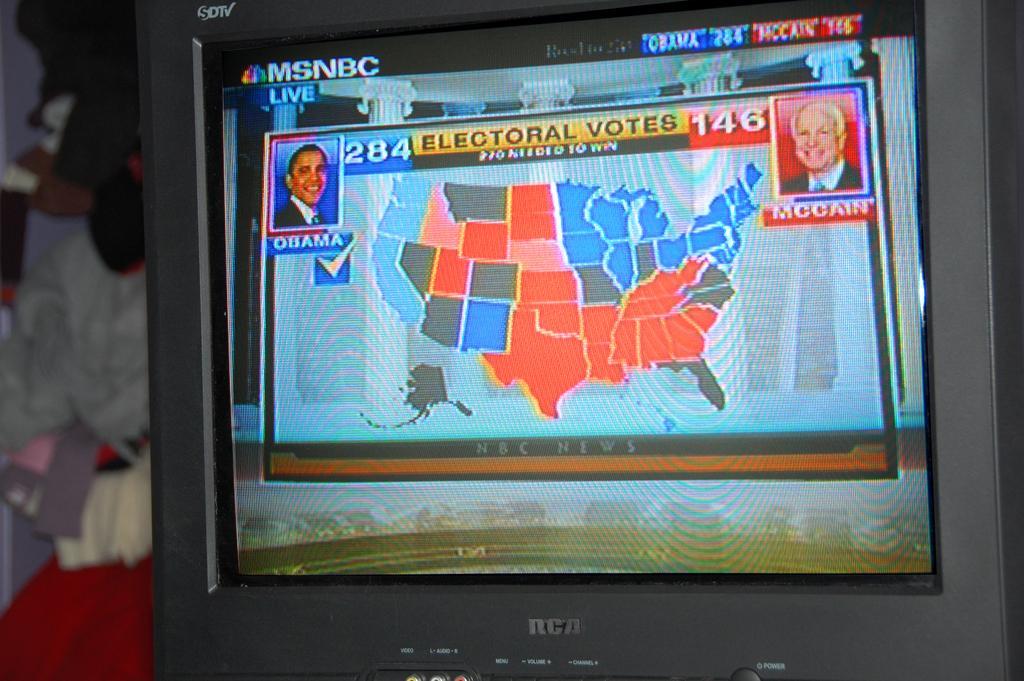Can you describe this image briefly? We can see screen, in this screen we can see people. In the background it is blur. 